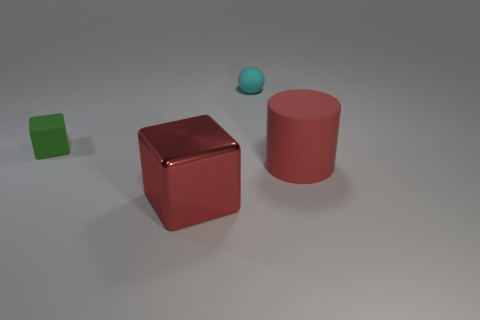There is another big object that is the same color as the large metallic object; what is its shape? The other large object that shares the same color as the metallic object is a cylinder. This shape is characterized by its circular base and straight, parallel sides. 